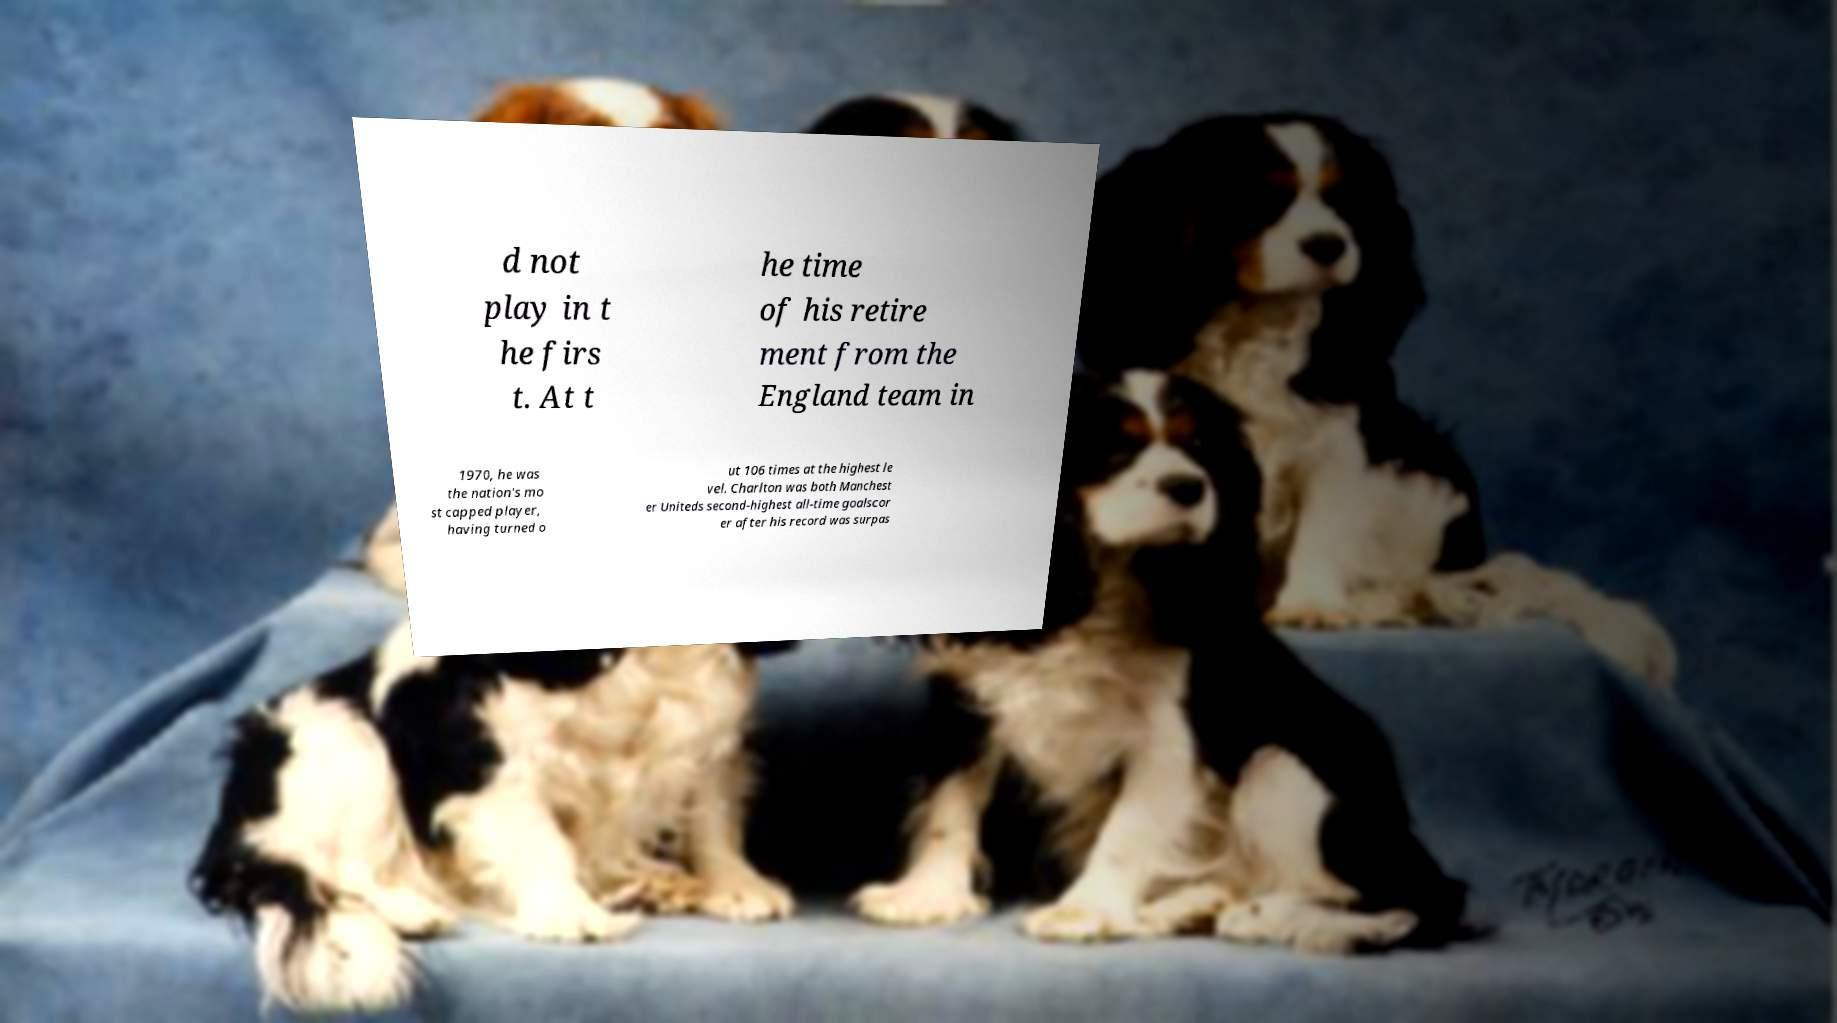Can you read and provide the text displayed in the image?This photo seems to have some interesting text. Can you extract and type it out for me? d not play in t he firs t. At t he time of his retire ment from the England team in 1970, he was the nation's mo st capped player, having turned o ut 106 times at the highest le vel. Charlton was both Manchest er Uniteds second-highest all-time goalscor er after his record was surpas 